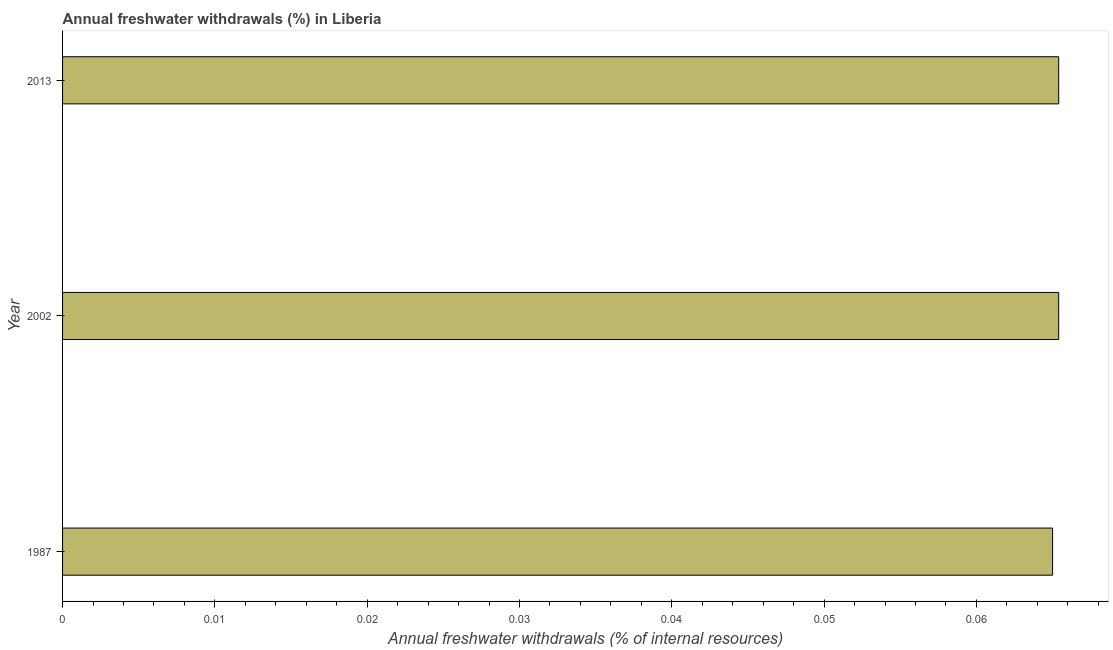What is the title of the graph?
Keep it short and to the point. Annual freshwater withdrawals (%) in Liberia. What is the label or title of the X-axis?
Give a very brief answer. Annual freshwater withdrawals (% of internal resources). What is the label or title of the Y-axis?
Your answer should be compact. Year. What is the annual freshwater withdrawals in 2013?
Ensure brevity in your answer.  0.07. Across all years, what is the maximum annual freshwater withdrawals?
Offer a terse response. 0.07. Across all years, what is the minimum annual freshwater withdrawals?
Ensure brevity in your answer.  0.07. In which year was the annual freshwater withdrawals minimum?
Give a very brief answer. 1987. What is the sum of the annual freshwater withdrawals?
Your response must be concise. 0.2. What is the difference between the annual freshwater withdrawals in 2002 and 2013?
Offer a terse response. 0. What is the average annual freshwater withdrawals per year?
Ensure brevity in your answer.  0.07. What is the median annual freshwater withdrawals?
Make the answer very short. 0.07. What is the ratio of the annual freshwater withdrawals in 2002 to that in 2013?
Offer a very short reply. 1. Is the annual freshwater withdrawals in 2002 less than that in 2013?
Keep it short and to the point. No. What is the difference between the highest and the second highest annual freshwater withdrawals?
Your answer should be very brief. 0. Is the sum of the annual freshwater withdrawals in 1987 and 2013 greater than the maximum annual freshwater withdrawals across all years?
Your answer should be very brief. Yes. In how many years, is the annual freshwater withdrawals greater than the average annual freshwater withdrawals taken over all years?
Provide a succinct answer. 2. Are all the bars in the graph horizontal?
Provide a succinct answer. Yes. Are the values on the major ticks of X-axis written in scientific E-notation?
Your answer should be very brief. No. What is the Annual freshwater withdrawals (% of internal resources) of 1987?
Your answer should be very brief. 0.07. What is the Annual freshwater withdrawals (% of internal resources) in 2002?
Offer a very short reply. 0.07. What is the Annual freshwater withdrawals (% of internal resources) of 2013?
Give a very brief answer. 0.07. What is the difference between the Annual freshwater withdrawals (% of internal resources) in 1987 and 2002?
Give a very brief answer. -0. What is the difference between the Annual freshwater withdrawals (% of internal resources) in 1987 and 2013?
Your answer should be compact. -0. What is the ratio of the Annual freshwater withdrawals (% of internal resources) in 1987 to that in 2002?
Your response must be concise. 0.99. What is the ratio of the Annual freshwater withdrawals (% of internal resources) in 1987 to that in 2013?
Offer a very short reply. 0.99. 